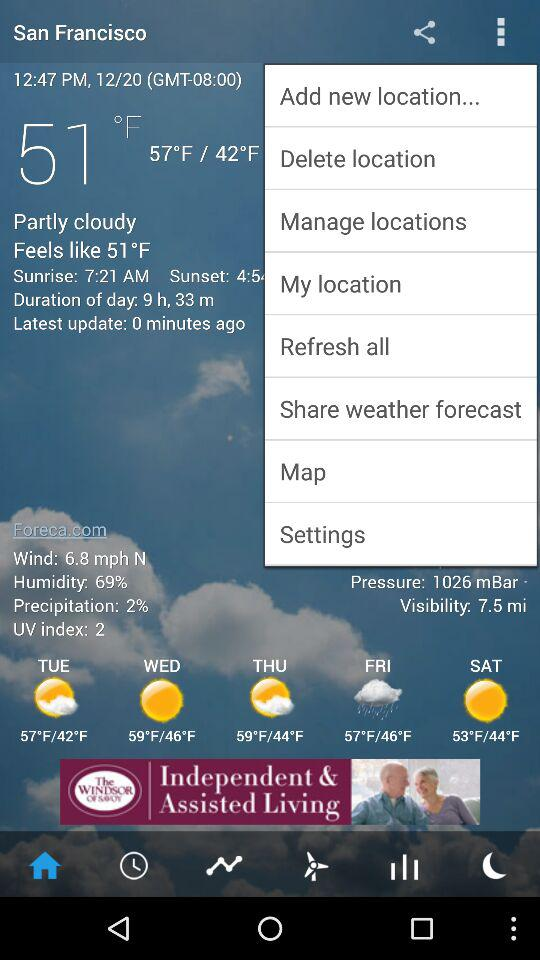How's the weather on Friday? The weather is rainy. 